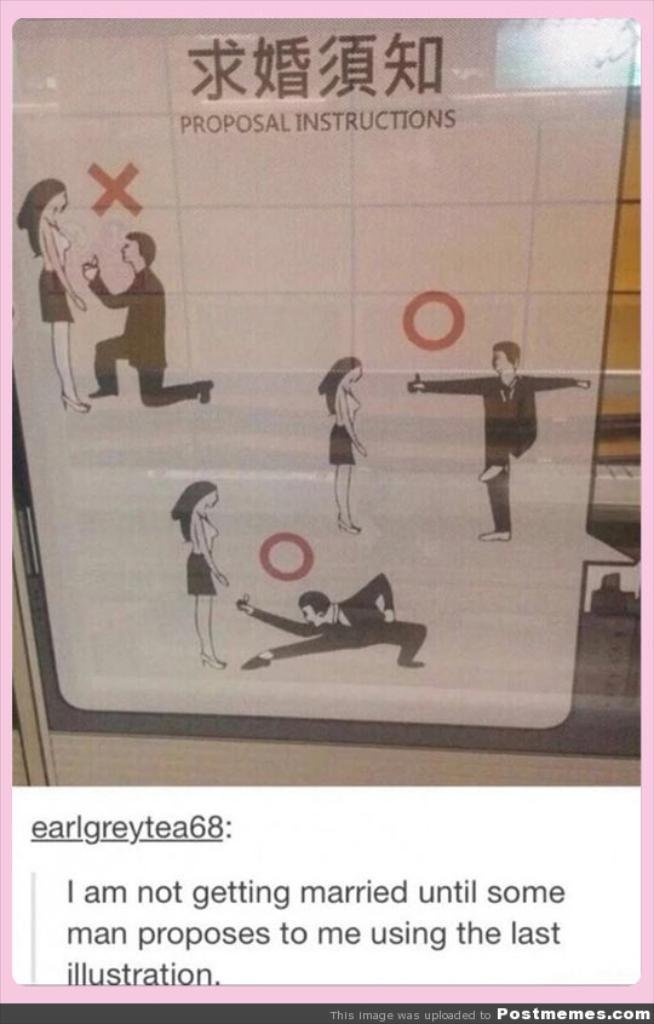Provide a one-sentence caption for the provided image. A proposal instructional guide is commented on by a user called earlgreytea68. 